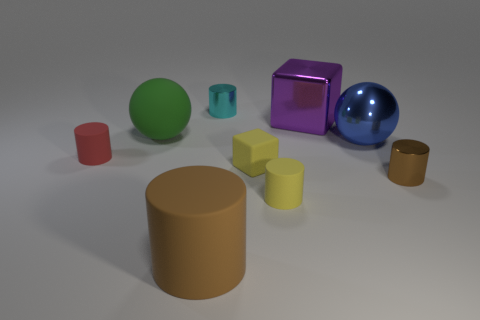Subtract all large cylinders. How many cylinders are left? 4 Subtract all yellow cylinders. How many cylinders are left? 4 Subtract all cyan cylinders. Subtract all cyan blocks. How many cylinders are left? 4 Subtract all spheres. How many objects are left? 7 Add 3 large blue metallic balls. How many large blue metallic balls exist? 4 Subtract 1 purple blocks. How many objects are left? 8 Subtract all cyan cylinders. Subtract all matte blocks. How many objects are left? 7 Add 6 spheres. How many spheres are left? 8 